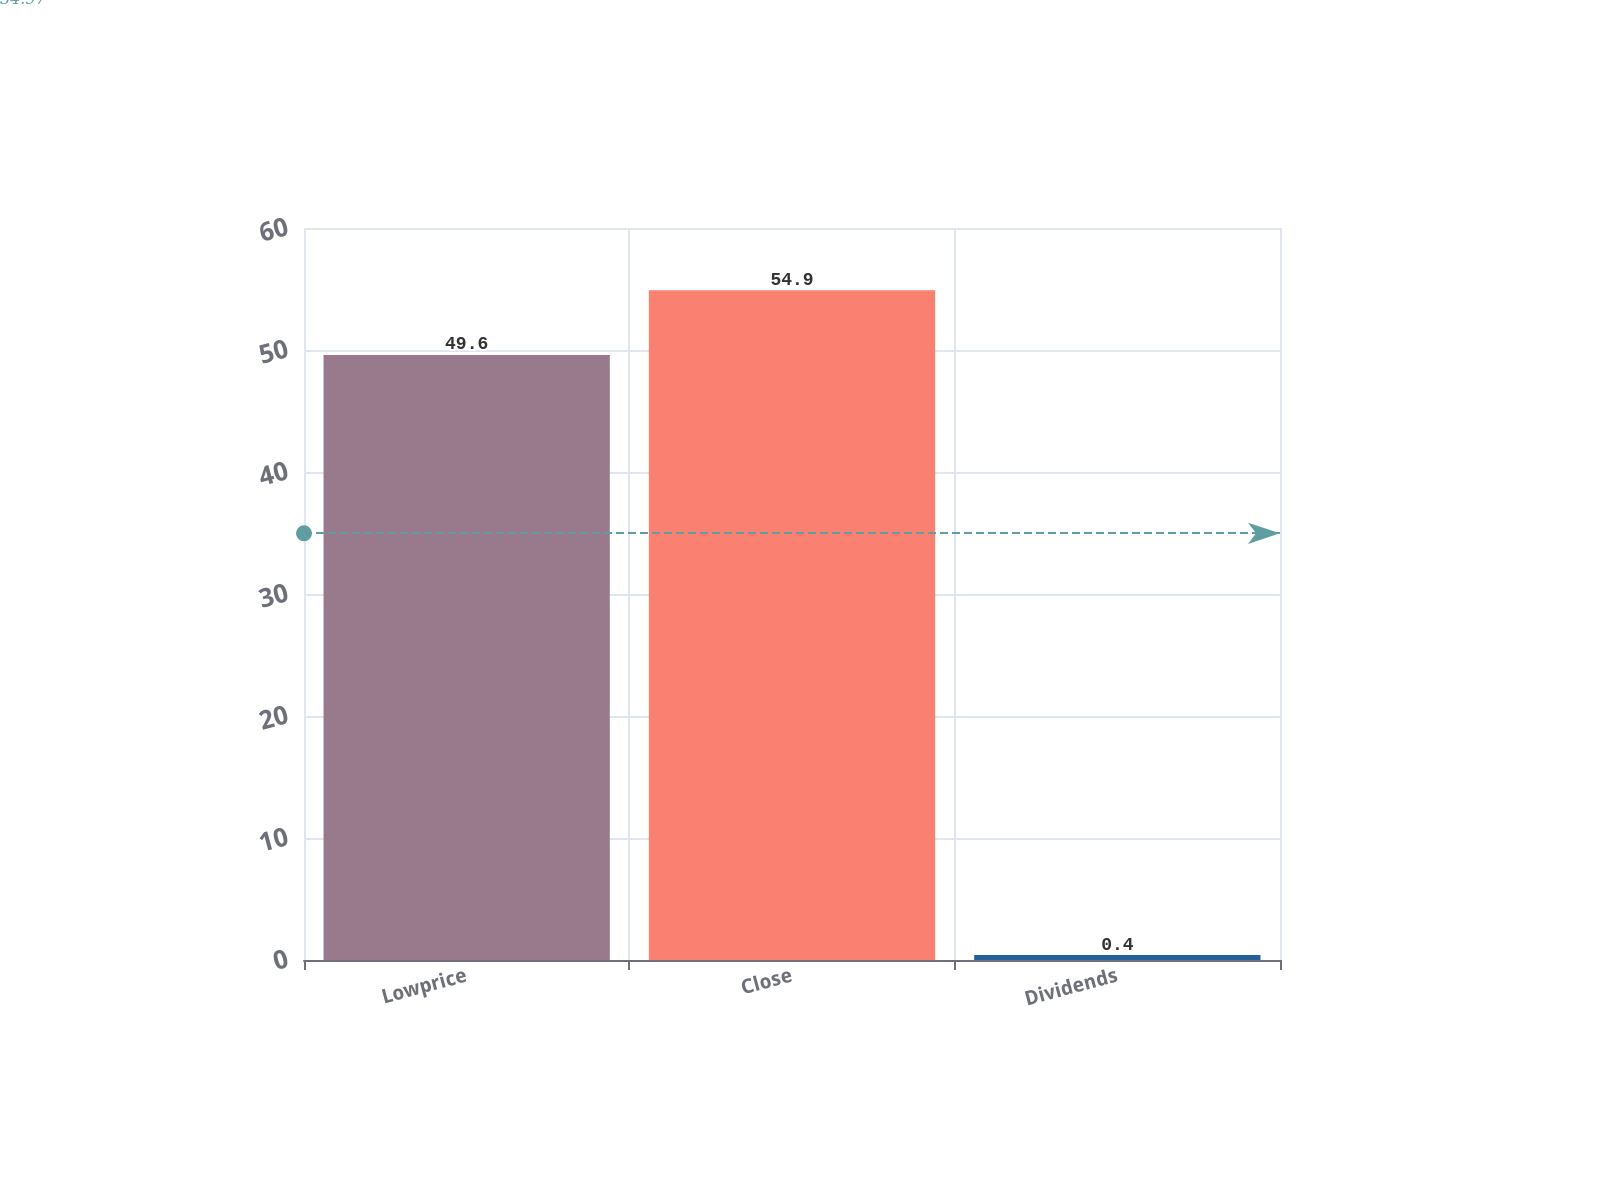Convert chart. <chart><loc_0><loc_0><loc_500><loc_500><bar_chart><fcel>Lowprice<fcel>Close<fcel>Dividends<nl><fcel>49.6<fcel>54.9<fcel>0.4<nl></chart> 